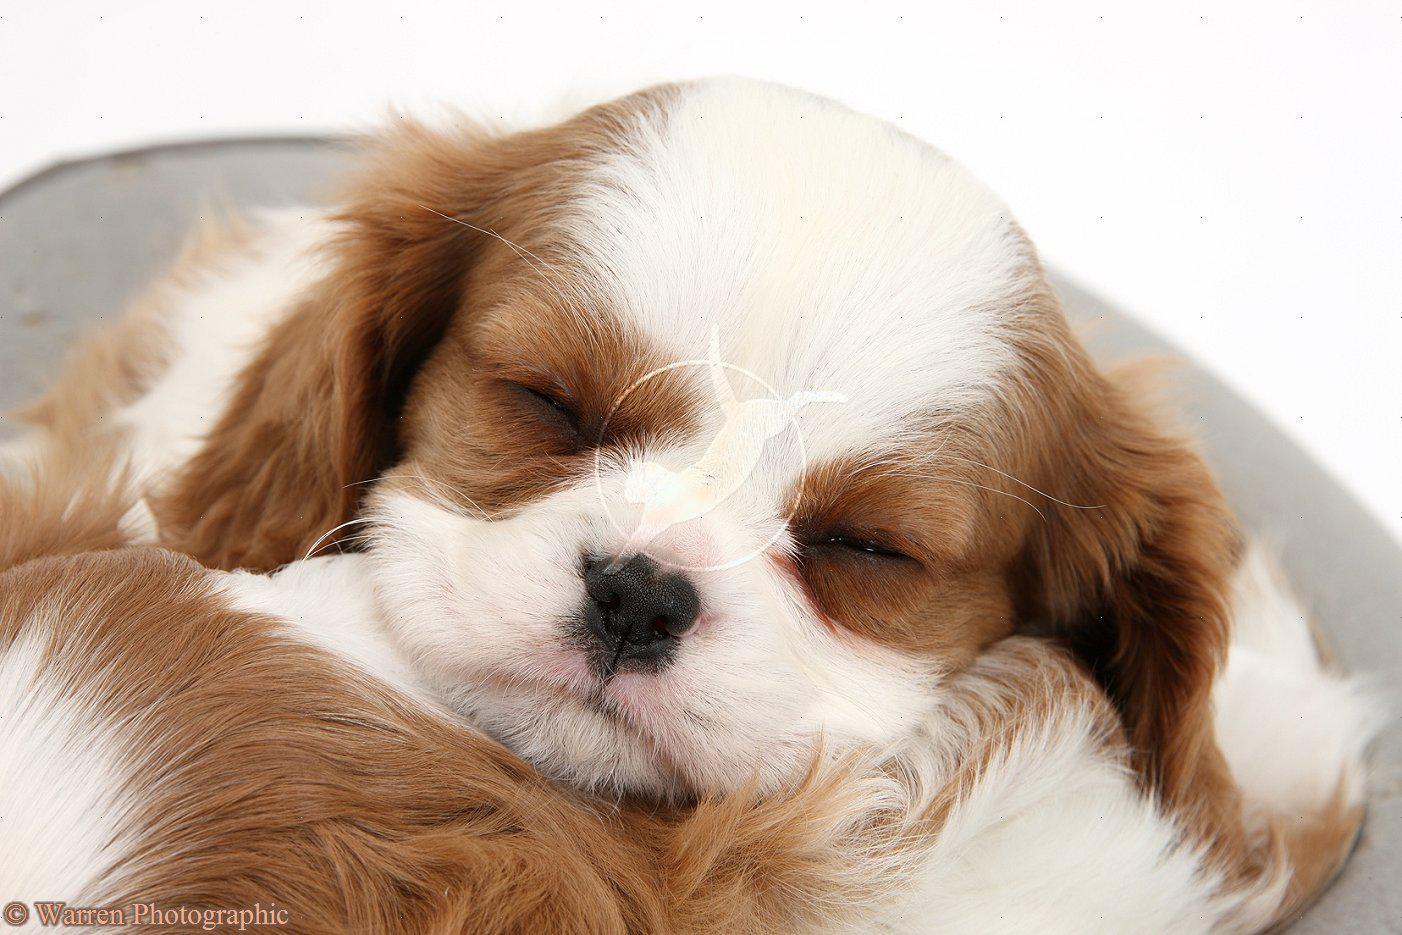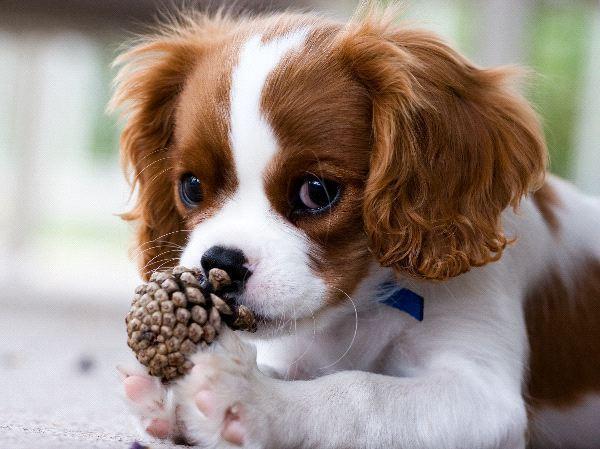The first image is the image on the left, the second image is the image on the right. Analyze the images presented: Is the assertion "In one of the images, the puppy is lying down with its chin resting on something" valid? Answer yes or no. Yes. The first image is the image on the left, the second image is the image on the right. For the images shown, is this caption "In one image there is a dog laying down while looking towards the camera." true? Answer yes or no. Yes. 